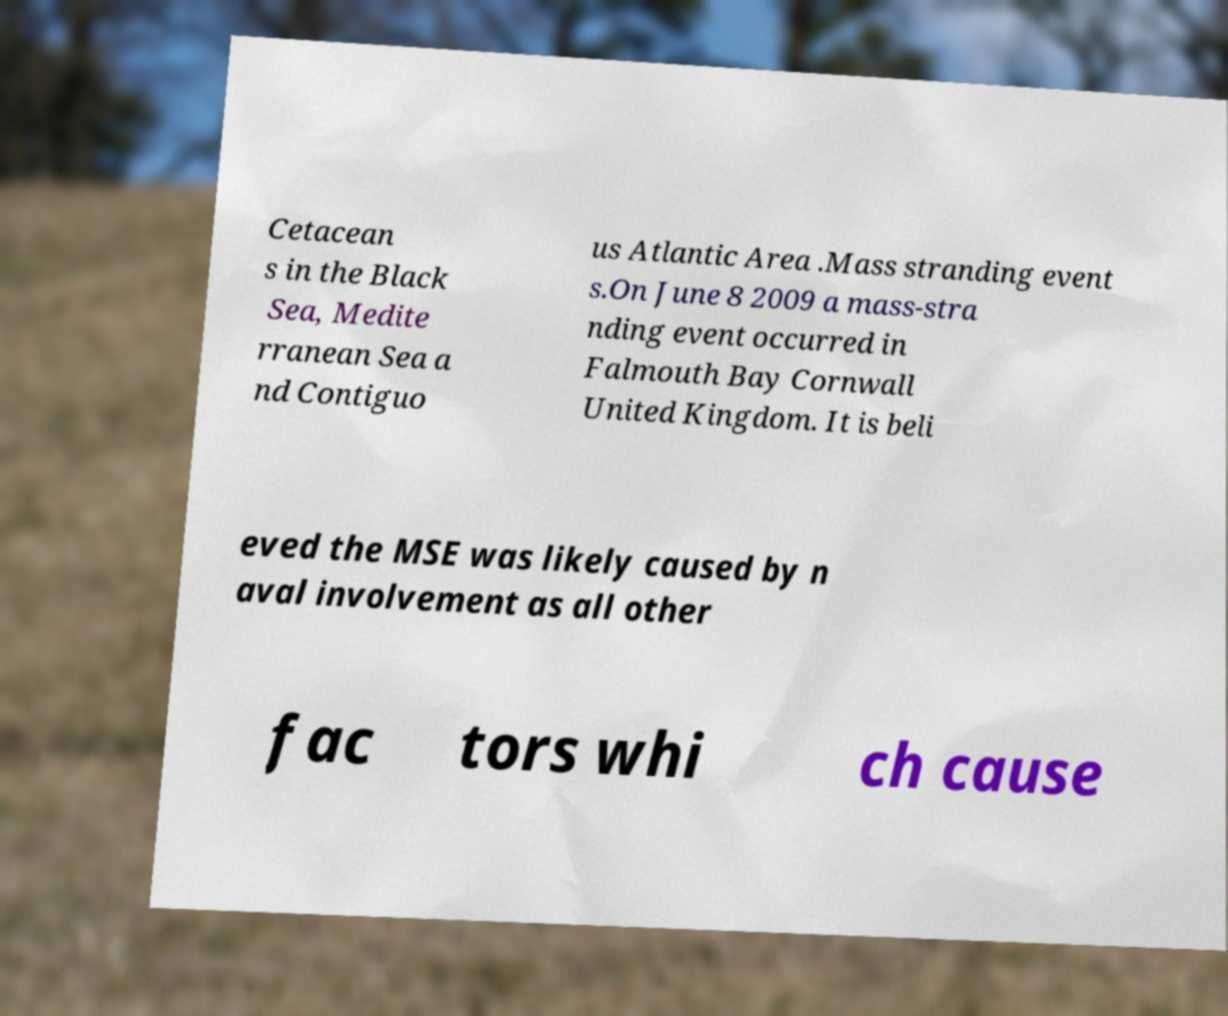Please read and relay the text visible in this image. What does it say? Cetacean s in the Black Sea, Medite rranean Sea a nd Contiguo us Atlantic Area .Mass stranding event s.On June 8 2009 a mass-stra nding event occurred in Falmouth Bay Cornwall United Kingdom. It is beli eved the MSE was likely caused by n aval involvement as all other fac tors whi ch cause 